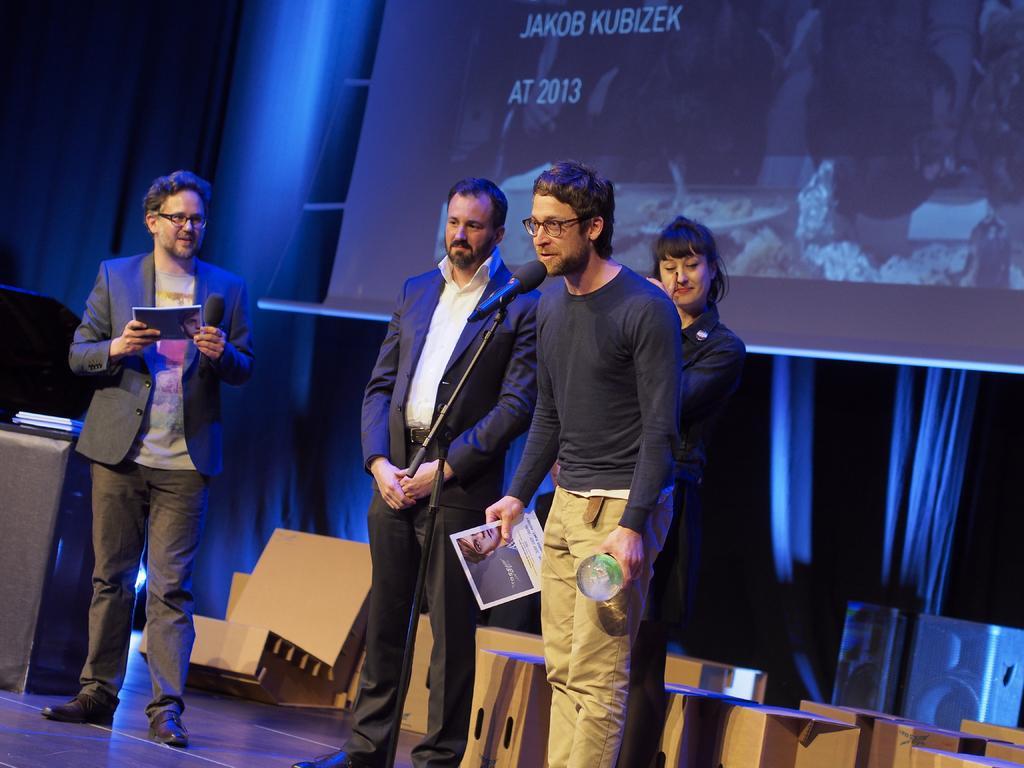Please provide a concise description of this image. In this image I can see the group of people with different color dresses. I can see one person standing in-front of the mic and holding the paper and the trophy. I can see one more person holding the mic and the paper. In the background I can see the brown color objects and the screen. 